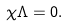<formula> <loc_0><loc_0><loc_500><loc_500>\chi \Lambda = 0 .</formula> 